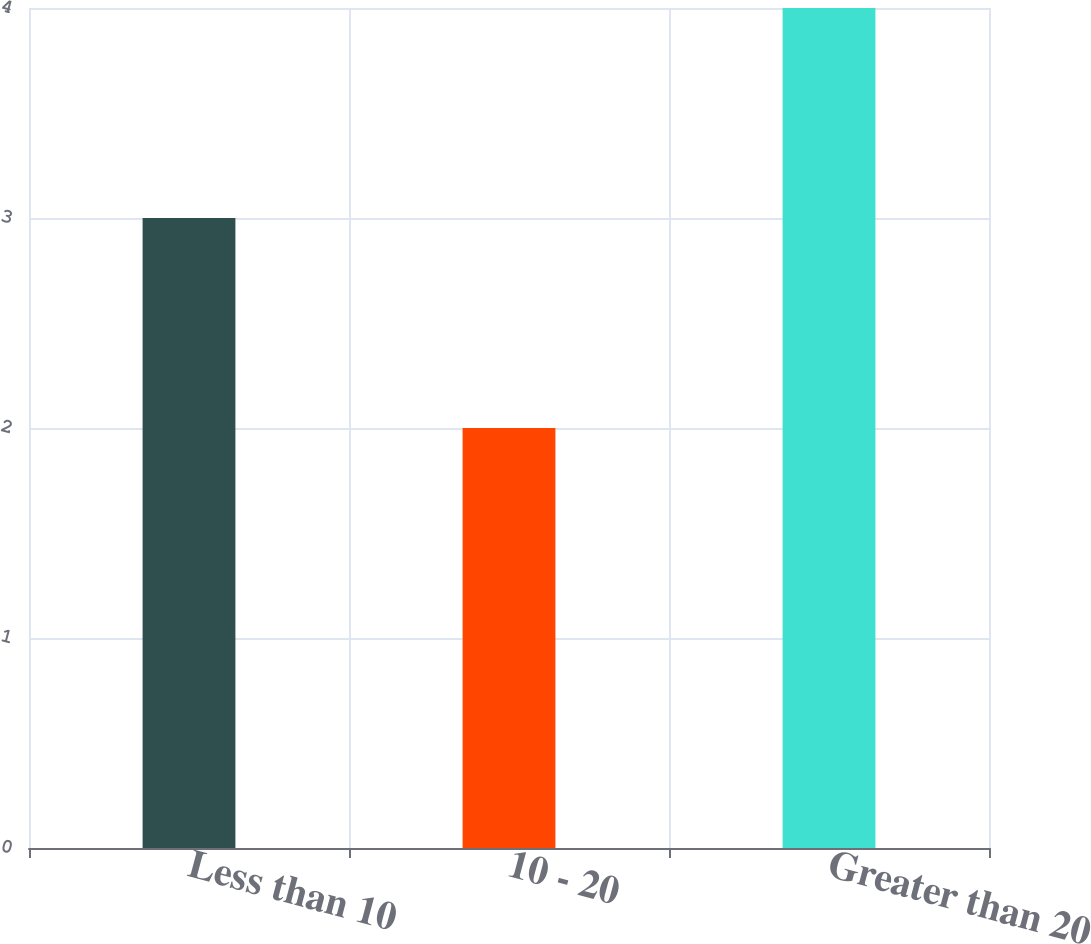Convert chart. <chart><loc_0><loc_0><loc_500><loc_500><bar_chart><fcel>Less than 10<fcel>10 - 20<fcel>Greater than 20<nl><fcel>3<fcel>2<fcel>4<nl></chart> 